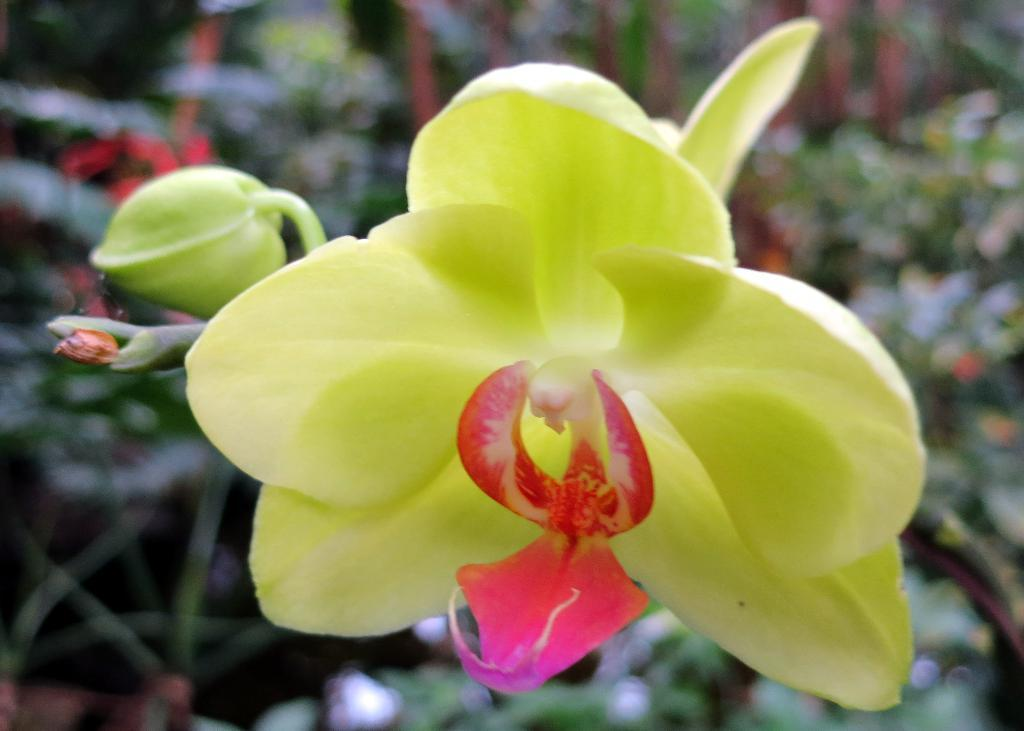What type of plant is visible in the image? There is a flower in the image. Can you describe the arrangement of the flowers in the image? There is another flower behind the first flower in the image. What other types of plants can be seen in the image? There are plants in the image. What type of person is depicted in the image? There is no person depicted in the image; it features flowers and plants. What type of sail can be seen in the image? There is no sail present in the image. 